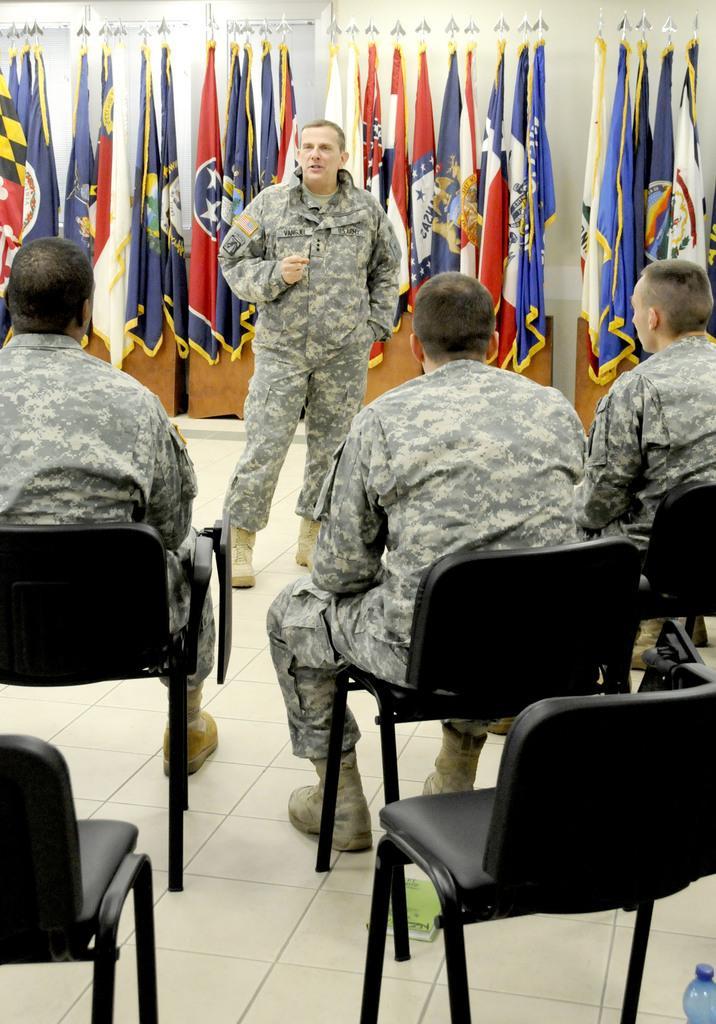Can you describe this image briefly? In this picture there are three people sitting on the chairs and a person standing in front them and behind the person there are some flags. 